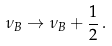Convert formula to latex. <formula><loc_0><loc_0><loc_500><loc_500>\nu _ { B } \rightarrow \nu _ { B } + \frac { 1 } { 2 } \, .</formula> 